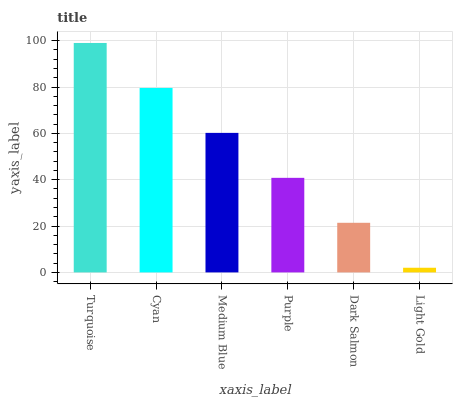Is Light Gold the minimum?
Answer yes or no. Yes. Is Turquoise the maximum?
Answer yes or no. Yes. Is Cyan the minimum?
Answer yes or no. No. Is Cyan the maximum?
Answer yes or no. No. Is Turquoise greater than Cyan?
Answer yes or no. Yes. Is Cyan less than Turquoise?
Answer yes or no. Yes. Is Cyan greater than Turquoise?
Answer yes or no. No. Is Turquoise less than Cyan?
Answer yes or no. No. Is Medium Blue the high median?
Answer yes or no. Yes. Is Purple the low median?
Answer yes or no. Yes. Is Cyan the high median?
Answer yes or no. No. Is Turquoise the low median?
Answer yes or no. No. 